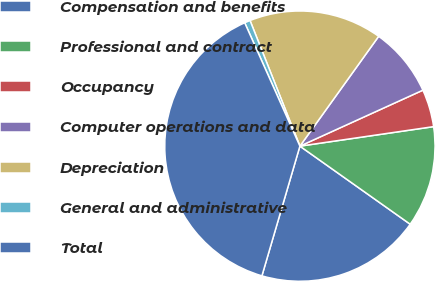Convert chart. <chart><loc_0><loc_0><loc_500><loc_500><pie_chart><fcel>Compensation and benefits<fcel>Professional and contract<fcel>Occupancy<fcel>Computer operations and data<fcel>Depreciation<fcel>General and administrative<fcel>Total<nl><fcel>19.73%<fcel>12.11%<fcel>4.49%<fcel>8.3%<fcel>15.92%<fcel>0.68%<fcel>38.77%<nl></chart> 